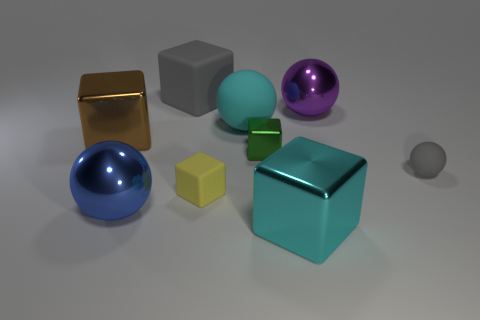Subtract all large cyan balls. How many balls are left? 3 Subtract all yellow cubes. How many cubes are left? 4 Subtract 3 cubes. How many cubes are left? 2 Subtract 1 gray blocks. How many objects are left? 8 Subtract all spheres. How many objects are left? 5 Subtract all blue spheres. Subtract all cyan blocks. How many spheres are left? 3 Subtract all green blocks. Subtract all tiny balls. How many objects are left? 7 Add 3 gray rubber things. How many gray rubber things are left? 5 Add 4 green blocks. How many green blocks exist? 5 